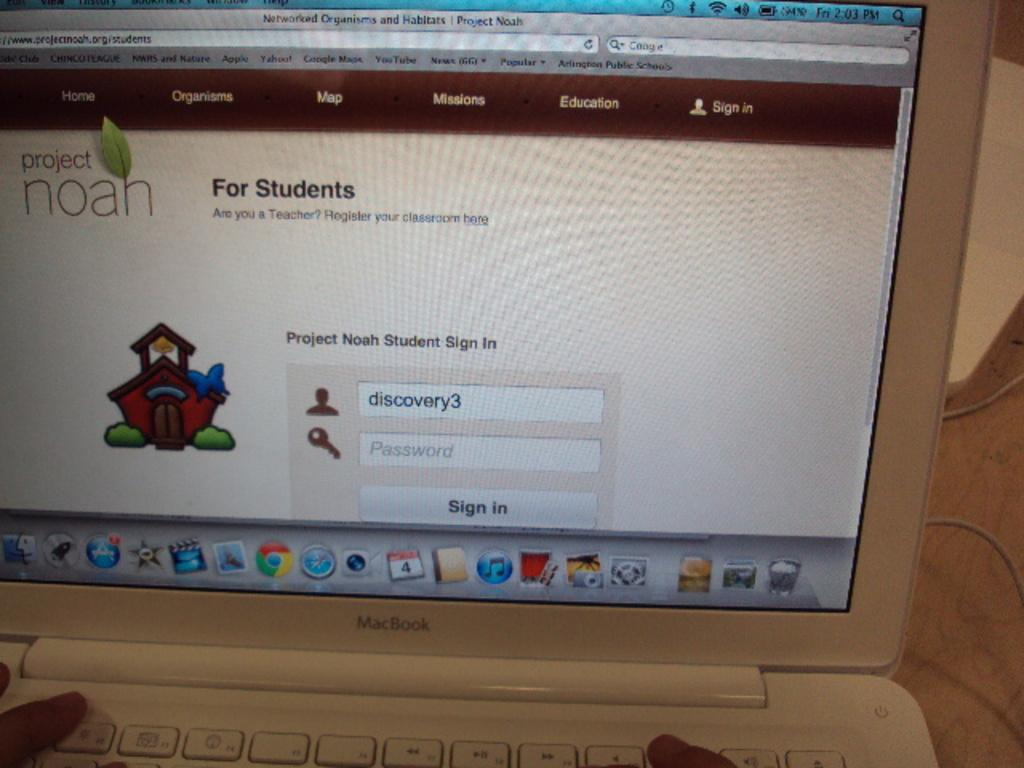<image>
Create a compact narrative representing the image presented. A laptop computer displays the sign in page for a site named Project Noah. 